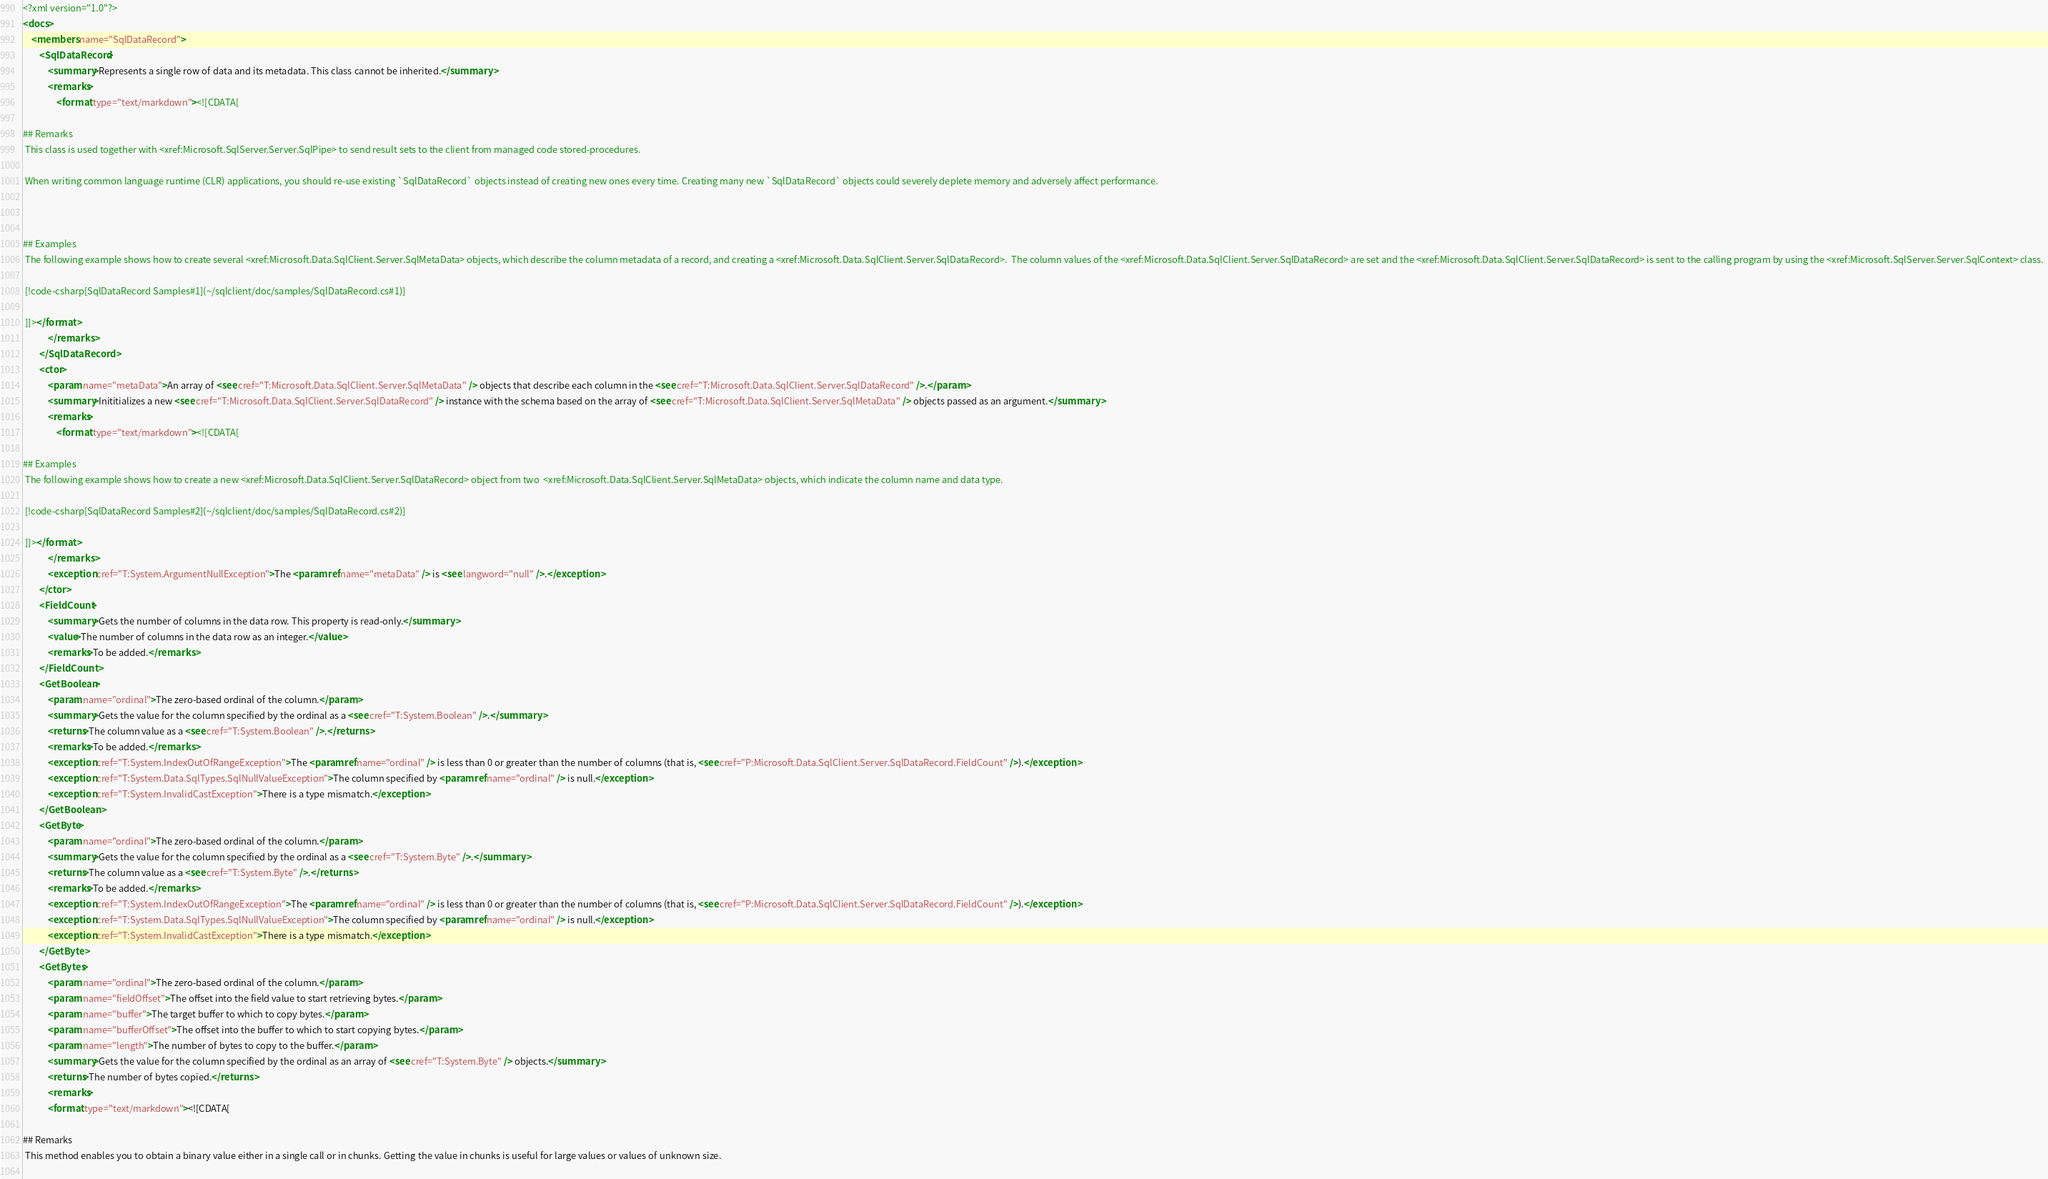<code> <loc_0><loc_0><loc_500><loc_500><_XML_><?xml version="1.0"?>
<docs>
    <members name="SqlDataRecord">
        <SqlDataRecord>
            <summary>Represents a single row of data and its metadata. This class cannot be inherited.</summary>
            <remarks>
                <format type="text/markdown"><![CDATA[  
  
## Remarks  
 This class is used together with <xref:Microsoft.SqlServer.Server.SqlPipe> to send result sets to the client from managed code stored-procedures.  
  
 When writing common language runtime (CLR) applications, you should re-use existing `SqlDataRecord` objects instead of creating new ones every time. Creating many new `SqlDataRecord` objects could severely deplete memory and adversely affect performance.  
  
   
  
## Examples  
 The following example shows how to create several <xref:Microsoft.Data.SqlClient.Server.SqlMetaData> objects, which describe the column metadata of a record, and creating a <xref:Microsoft.Data.SqlClient.Server.SqlDataRecord>.  The column values of the <xref:Microsoft.Data.SqlClient.Server.SqlDataRecord> are set and the <xref:Microsoft.Data.SqlClient.Server.SqlDataRecord> is sent to the calling program by using the <xref:Microsoft.SqlServer.Server.SqlContext> class.  
  
 [!code-csharp[SqlDataRecord Samples#1](~/sqlclient/doc/samples/SqlDataRecord.cs#1)]
  
 ]]></format>
            </remarks>
        </SqlDataRecord>
        <ctor>
            <param name="metaData">An array of <see cref="T:Microsoft.Data.SqlClient.Server.SqlMetaData" /> objects that describe each column in the <see cref="T:Microsoft.Data.SqlClient.Server.SqlDataRecord" />.</param>
            <summary>Inititializes a new <see cref="T:Microsoft.Data.SqlClient.Server.SqlDataRecord" /> instance with the schema based on the array of <see cref="T:Microsoft.Data.SqlClient.Server.SqlMetaData" /> objects passed as an argument.</summary>
            <remarks>
                <format type="text/markdown"><![CDATA[  
  
## Examples  
 The following example shows how to create a new <xref:Microsoft.Data.SqlClient.Server.SqlDataRecord> object from two  <xref:Microsoft.Data.SqlClient.Server.SqlMetaData> objects, which indicate the column name and data type.  
  
 [!code-csharp[SqlDataRecord Samples#2](~/sqlclient/doc/samples/SqlDataRecord.cs#2)]
  
 ]]></format>
            </remarks>
            <exception cref="T:System.ArgumentNullException">The <paramref name="metaData" /> is <see langword="null" />.</exception>
        </ctor>
        <FieldCount>
            <summary>Gets the number of columns in the data row. This property is read-only.</summary>
            <value>The number of columns in the data row as an integer.</value>
            <remarks>To be added.</remarks>
        </FieldCount>
        <GetBoolean>
            <param name="ordinal">The zero-based ordinal of the column.</param>
            <summary>Gets the value for the column specified by the ordinal as a <see cref="T:System.Boolean" />.</summary>
            <returns>The column value as a <see cref="T:System.Boolean" />.</returns>
            <remarks>To be added.</remarks>
            <exception cref="T:System.IndexOutOfRangeException">The <paramref name="ordinal" /> is less than 0 or greater than the number of columns (that is, <see cref="P:Microsoft.Data.SqlClient.Server.SqlDataRecord.FieldCount" />).</exception>
            <exception cref="T:System.Data.SqlTypes.SqlNullValueException">The column specified by <paramref name="ordinal" /> is null.</exception>
            <exception cref="T:System.InvalidCastException">There is a type mismatch.</exception>
        </GetBoolean>
        <GetByte>
            <param name="ordinal">The zero-based ordinal of the column.</param>
            <summary>Gets the value for the column specified by the ordinal as a <see cref="T:System.Byte" />.</summary>
            <returns>The column value as a <see cref="T:System.Byte" />.</returns>
            <remarks>To be added.</remarks>
            <exception cref="T:System.IndexOutOfRangeException">The <paramref name="ordinal" /> is less than 0 or greater than the number of columns (that is, <see cref="P:Microsoft.Data.SqlClient.Server.SqlDataRecord.FieldCount" />).</exception>
            <exception cref="T:System.Data.SqlTypes.SqlNullValueException">The column specified by <paramref name="ordinal" /> is null.</exception>
            <exception cref="T:System.InvalidCastException">There is a type mismatch.</exception>
        </GetByte>
        <GetBytes>
            <param name="ordinal">The zero-based ordinal of the column.</param>
            <param name="fieldOffset">The offset into the field value to start retrieving bytes.</param>
            <param name="buffer">The target buffer to which to copy bytes.</param>
            <param name="bufferOffset">The offset into the buffer to which to start copying bytes.</param>
            <param name="length">The number of bytes to copy to the buffer.</param>
            <summary>Gets the value for the column specified by the ordinal as an array of <see cref="T:System.Byte" /> objects.</summary>
            <returns>The number of bytes copied.</returns>
            <remarks>
            <format type="text/markdown"><![CDATA[  
  
## Remarks  
 This method enables you to obtain a binary value either in a single call or in chunks. Getting the value in chunks is useful for large values or values of unknown size.  
  </code> 